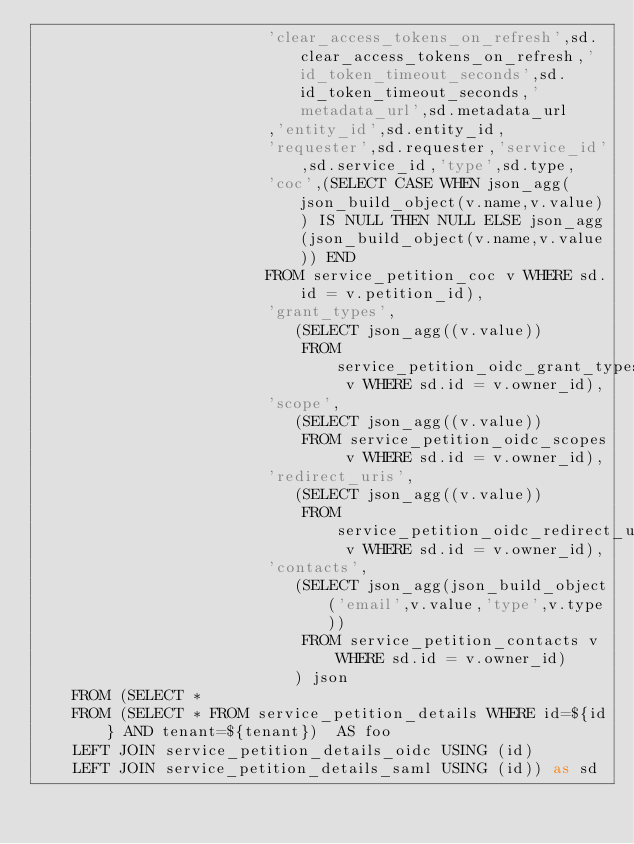Convert code to text. <code><loc_0><loc_0><loc_500><loc_500><_SQL_>						 'clear_access_tokens_on_refresh',sd.clear_access_tokens_on_refresh,'id_token_timeout_seconds',sd.id_token_timeout_seconds,'metadata_url',sd.metadata_url
						 ,'entity_id',sd.entity_id,
						 'requester',sd.requester,'service_id',sd.service_id,'type',sd.type,
						 'coc',(SELECT CASE WHEN json_agg(json_build_object(v.name,v.value)) IS NULL THEN NULL ELSE json_agg(json_build_object(v.name,v.value)) END
						 FROM service_petition_coc v WHERE sd.id = v.petition_id),
						 'grant_types',
							(SELECT json_agg((v.value))
							 FROM service_petition_oidc_grant_types v WHERE sd.id = v.owner_id),
						 'scope',
						 	(SELECT json_agg((v.value))
							 FROM service_petition_oidc_scopes v WHERE sd.id = v.owner_id),
						 'redirect_uris',
						 	(SELECT json_agg((v.value))
							 FROM service_petition_oidc_redirect_uris v WHERE sd.id = v.owner_id),
						 'contacts',
						 	(SELECT json_agg(json_build_object('email',v.value,'type',v.type))
							 FROM service_petition_contacts v WHERE sd.id = v.owner_id)
							) json
    FROM (SELECT *
	FROM (SELECT * FROM service_petition_details WHERE id=${id} AND tenant=${tenant})  AS foo
	LEFT JOIN service_petition_details_oidc USING (id)
	LEFT JOIN service_petition_details_saml USING (id)) as sd
</code> 